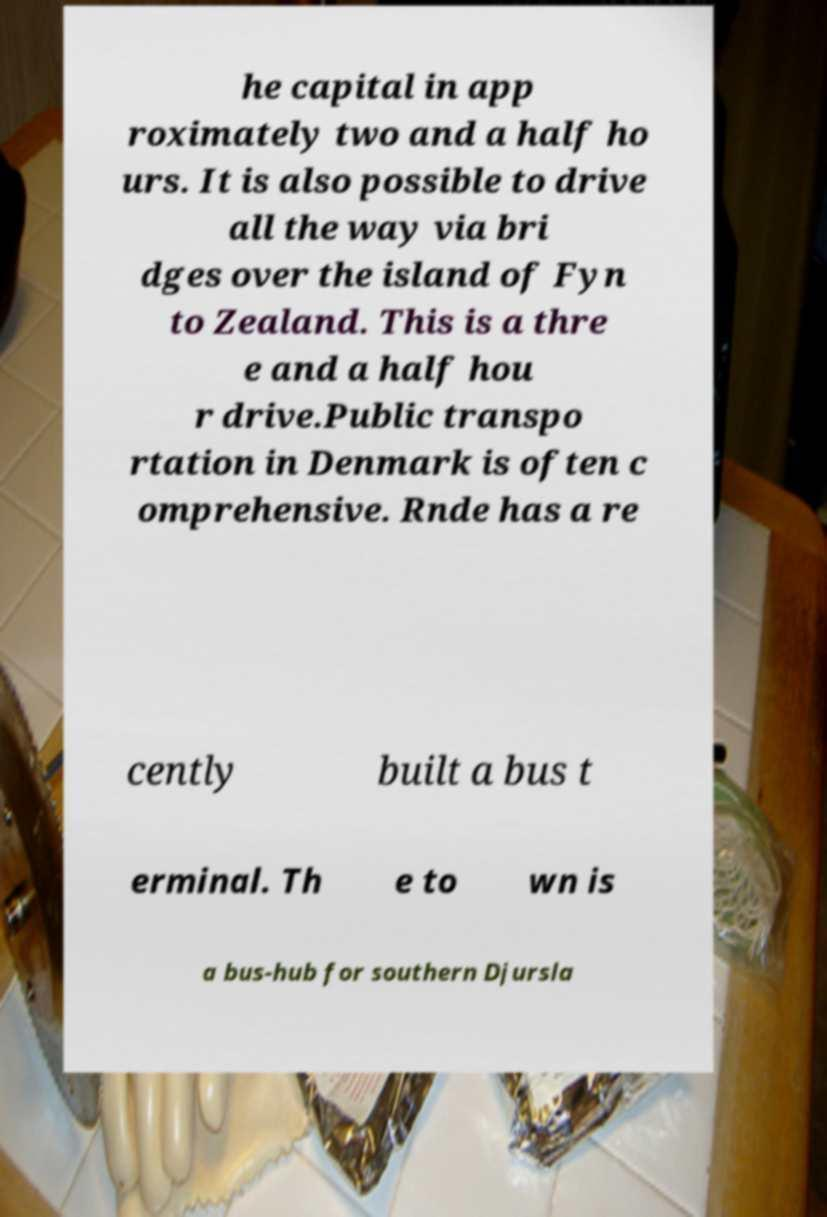For documentation purposes, I need the text within this image transcribed. Could you provide that? he capital in app roximately two and a half ho urs. It is also possible to drive all the way via bri dges over the island of Fyn to Zealand. This is a thre e and a half hou r drive.Public transpo rtation in Denmark is often c omprehensive. Rnde has a re cently built a bus t erminal. Th e to wn is a bus-hub for southern Djursla 